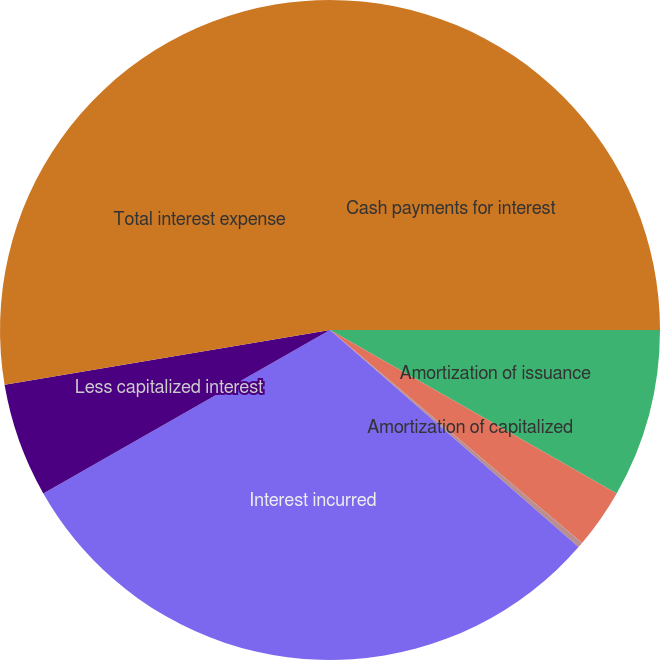Convert chart to OTSL. <chart><loc_0><loc_0><loc_500><loc_500><pie_chart><fcel>Cash payments for interest<fcel>Amortization of issuance<fcel>Amortization of capitalized<fcel>Net changes in accruals<fcel>Interest incurred<fcel>Less capitalized interest<fcel>Total interest expense<nl><fcel>25.0%<fcel>8.25%<fcel>2.92%<fcel>0.26%<fcel>30.33%<fcel>5.59%<fcel>27.66%<nl></chart> 